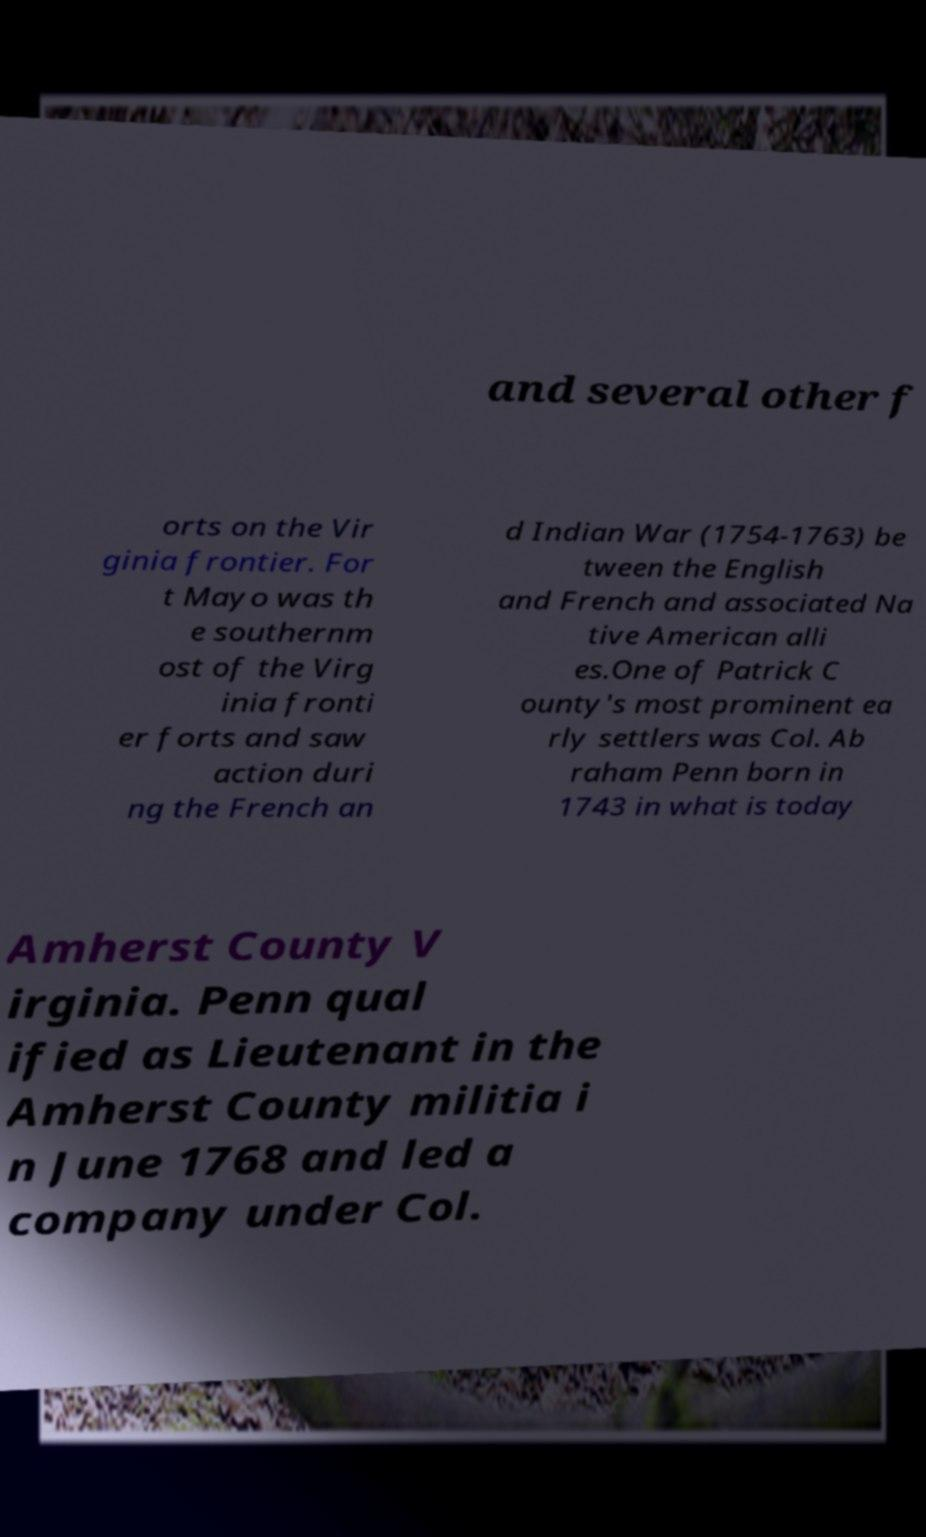Could you extract and type out the text from this image? and several other f orts on the Vir ginia frontier. For t Mayo was th e southernm ost of the Virg inia fronti er forts and saw action duri ng the French an d Indian War (1754-1763) be tween the English and French and associated Na tive American alli es.One of Patrick C ounty's most prominent ea rly settlers was Col. Ab raham Penn born in 1743 in what is today Amherst County V irginia. Penn qual ified as Lieutenant in the Amherst County militia i n June 1768 and led a company under Col. 